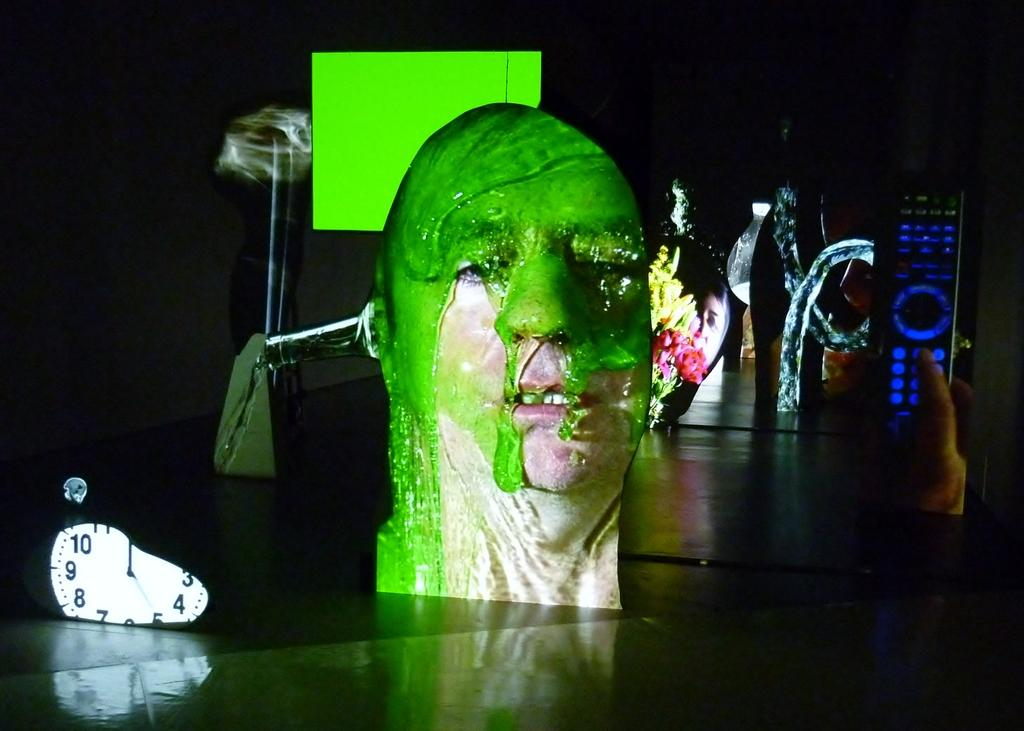What is the main subject of the image? There is a depiction of a person's face in the image. What other object can be seen in the image? There is a clock in the image. What is the person in the image doing? A person's hand is holding a remote in the image. Can you describe the background of the image? The background of the image is dark. What other objects are present in the image? There are other objects in the image, but their specific details are not mentioned in the provided facts. What type of support system is visible in the image? There is no support system present in the image. Can you tell me how many tents are set up in the camp shown in the image? There is no camp or tents present in the image. 